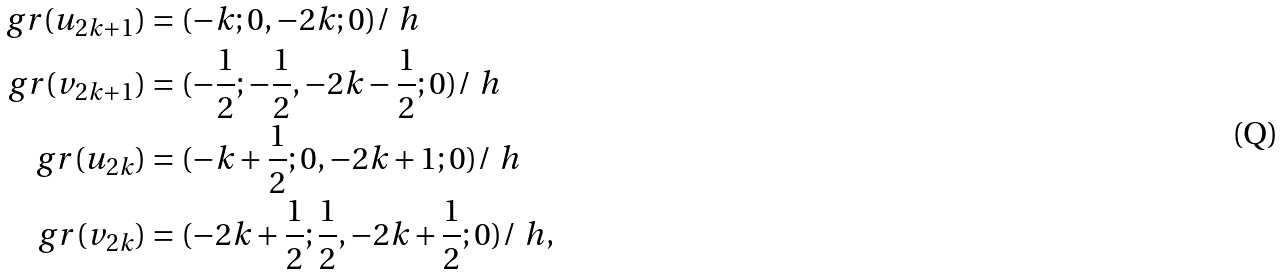Convert formula to latex. <formula><loc_0><loc_0><loc_500><loc_500>g r ( u _ { 2 k + 1 } ) & = ( - k ; 0 , - 2 k ; 0 ) / \ h \\ g r ( v _ { 2 k + 1 } ) & = ( - \frac { 1 } { 2 } ; - \frac { 1 } { 2 } , - 2 k - \frac { 1 } { 2 } ; 0 ) / \ h \\ g r ( u _ { 2 k } ) & = ( - k + \frac { 1 } { 2 } ; 0 , - 2 k + 1 ; 0 ) / \ h \\ g r ( v _ { 2 k } ) & = ( - 2 k + \frac { 1 } { 2 } ; \frac { 1 } { 2 } , - 2 k + \frac { 1 } { 2 } ; 0 ) / \ h ,</formula> 